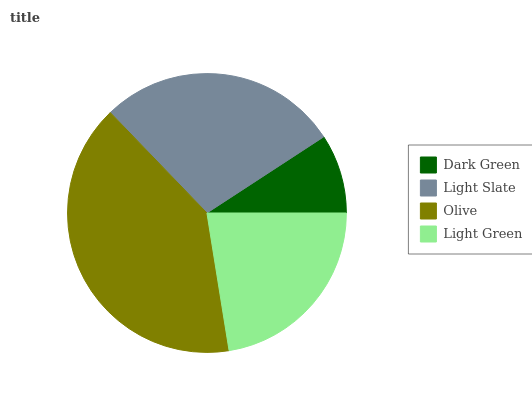Is Dark Green the minimum?
Answer yes or no. Yes. Is Olive the maximum?
Answer yes or no. Yes. Is Light Slate the minimum?
Answer yes or no. No. Is Light Slate the maximum?
Answer yes or no. No. Is Light Slate greater than Dark Green?
Answer yes or no. Yes. Is Dark Green less than Light Slate?
Answer yes or no. Yes. Is Dark Green greater than Light Slate?
Answer yes or no. No. Is Light Slate less than Dark Green?
Answer yes or no. No. Is Light Slate the high median?
Answer yes or no. Yes. Is Light Green the low median?
Answer yes or no. Yes. Is Olive the high median?
Answer yes or no. No. Is Dark Green the low median?
Answer yes or no. No. 